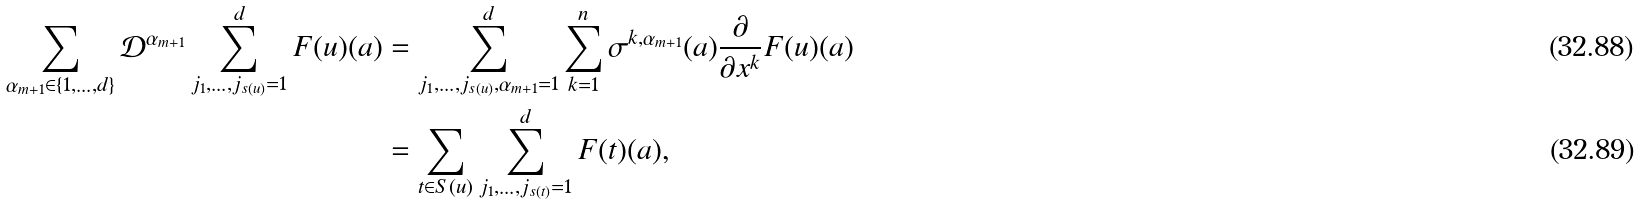Convert formula to latex. <formula><loc_0><loc_0><loc_500><loc_500>\sum _ { \alpha _ { m + 1 } \in \{ 1 , \dots , d \} } \mathcal { D } ^ { \alpha _ { m + 1 } } \sum _ { j _ { 1 } , \dots , j _ { s ( u ) } = 1 } ^ { d } F ( u ) ( a ) & = \sum _ { j _ { 1 } , \dots , j _ { s ( u ) } , \alpha _ { m + 1 } = 1 } ^ { d } \sum _ { k = 1 } ^ { n } \sigma ^ { k , \alpha _ { m + 1 } } ( a ) \frac { \partial } { \partial x ^ { k } } F ( u ) ( a ) \\ & = \sum _ { t \in S ( u ) } \sum _ { j _ { 1 } , \dots , j _ { s ( t ) } = 1 } ^ { d } F ( t ) ( a ) ,</formula> 